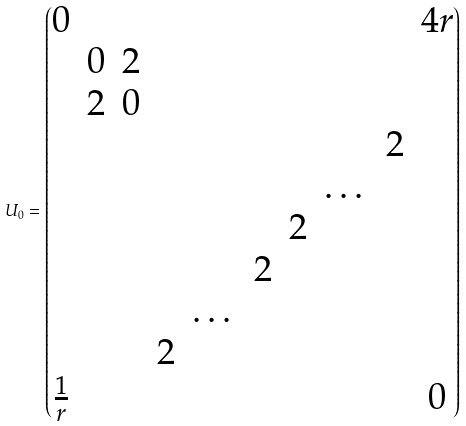Convert formula to latex. <formula><loc_0><loc_0><loc_500><loc_500>U _ { 0 } = \begin{pmatrix} 0 & & & & & & & & & 4 r \\ & 0 & 2 & & & & & & & \\ & 2 & 0 & & & & & & & \\ & & & & & & & & 2 & \\ & & & & & & & \dots & & \\ & & & & & & 2 & & & \\ & & & & & 2 & & & & \\ & & & & \dots & & & & & \\ & & & 2 & & & & & & \\ \frac { 1 } { r } & & & & & & & & & 0 \\ \end{pmatrix}</formula> 